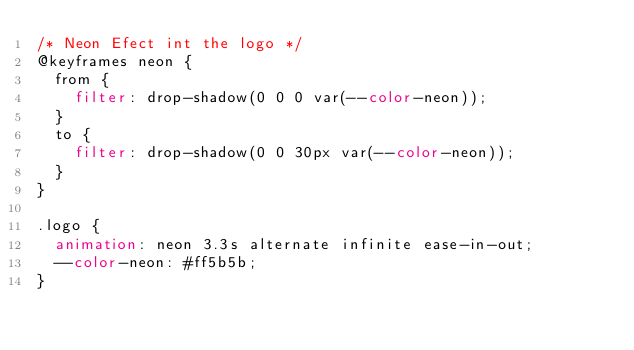Convert code to text. <code><loc_0><loc_0><loc_500><loc_500><_CSS_>/* Neon Efect int the logo */
@keyframes neon {
  from {
    filter: drop-shadow(0 0 0 var(--color-neon));
  }
  to {
    filter: drop-shadow(0 0 30px var(--color-neon));
  }
}

.logo {
  animation: neon 3.3s alternate infinite ease-in-out;
  --color-neon: #ff5b5b;
}
</code> 